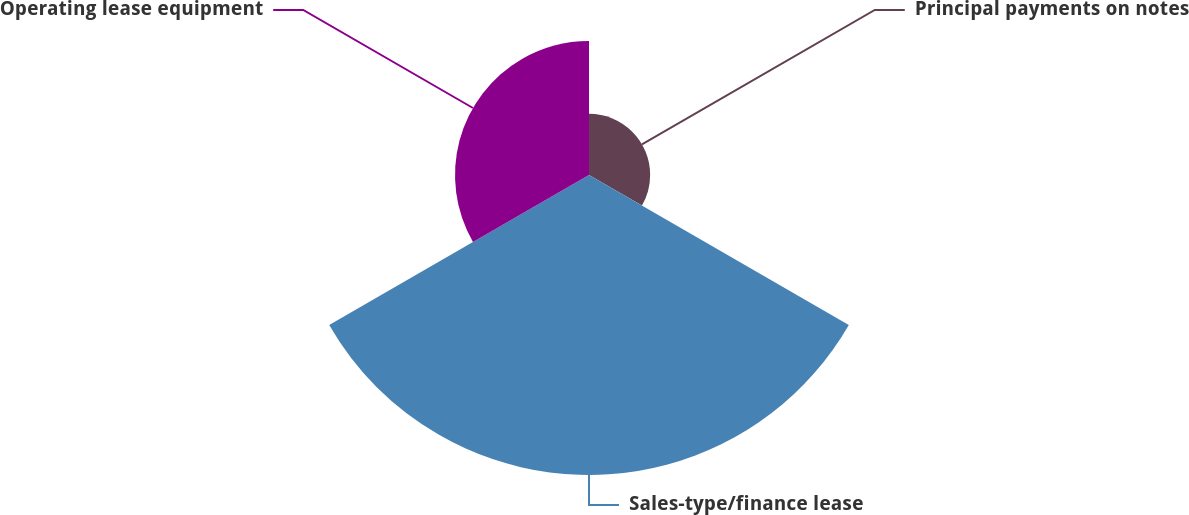Convert chart. <chart><loc_0><loc_0><loc_500><loc_500><pie_chart><fcel>Principal payments on notes<fcel>Sales-type/finance lease<fcel>Operating lease equipment<nl><fcel>12.35%<fcel>60.59%<fcel>27.06%<nl></chart> 